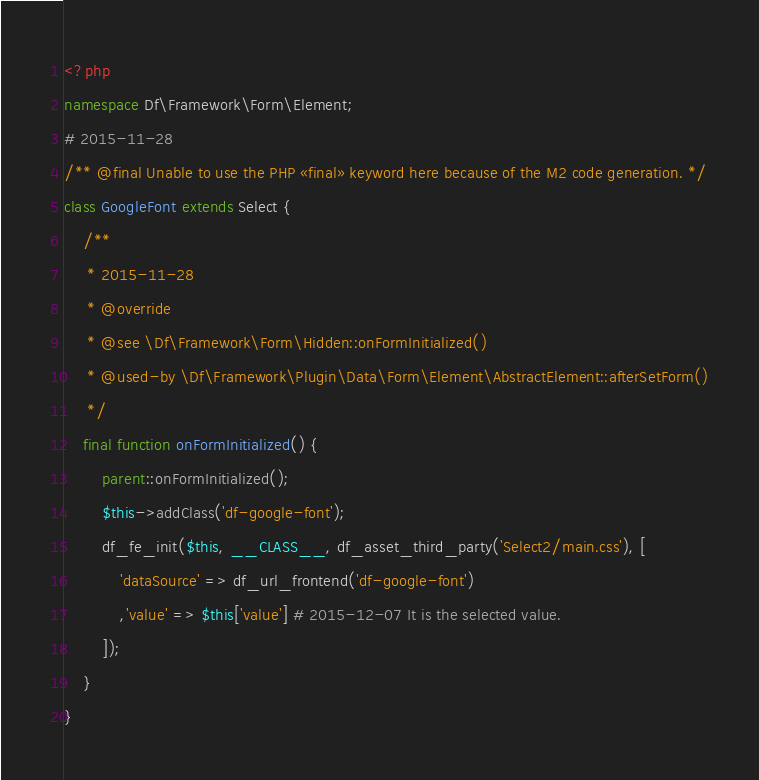<code> <loc_0><loc_0><loc_500><loc_500><_PHP_><?php
namespace Df\Framework\Form\Element;
# 2015-11-28
/** @final Unable to use the PHP «final» keyword here because of the M2 code generation. */
class GoogleFont extends Select {
	/**
	 * 2015-11-28
	 * @override
	 * @see \Df\Framework\Form\Hidden::onFormInitialized()
	 * @used-by \Df\Framework\Plugin\Data\Form\Element\AbstractElement::afterSetForm()
	 */
	final function onFormInitialized() {
		parent::onFormInitialized();
		$this->addClass('df-google-font');
		df_fe_init($this, __CLASS__, df_asset_third_party('Select2/main.css'), [
			'dataSource' => df_url_frontend('df-google-font')
			,'value' => $this['value'] # 2015-12-07 It is the selected value.
		]);
	}
}</code> 